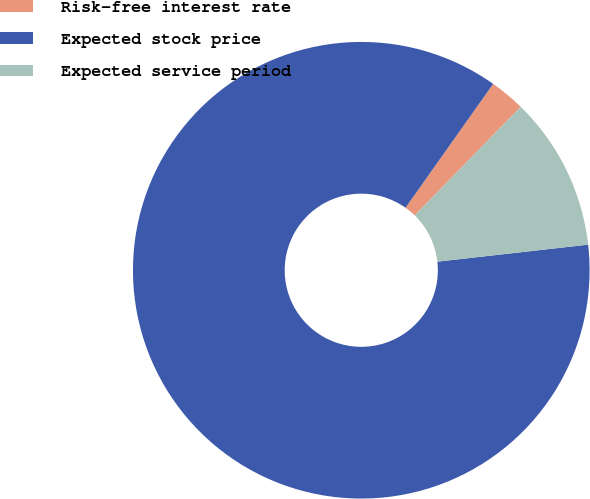Convert chart to OTSL. <chart><loc_0><loc_0><loc_500><loc_500><pie_chart><fcel>Risk-free interest rate<fcel>Expected stock price<fcel>Expected service period<nl><fcel>2.5%<fcel>86.59%<fcel>10.91%<nl></chart> 